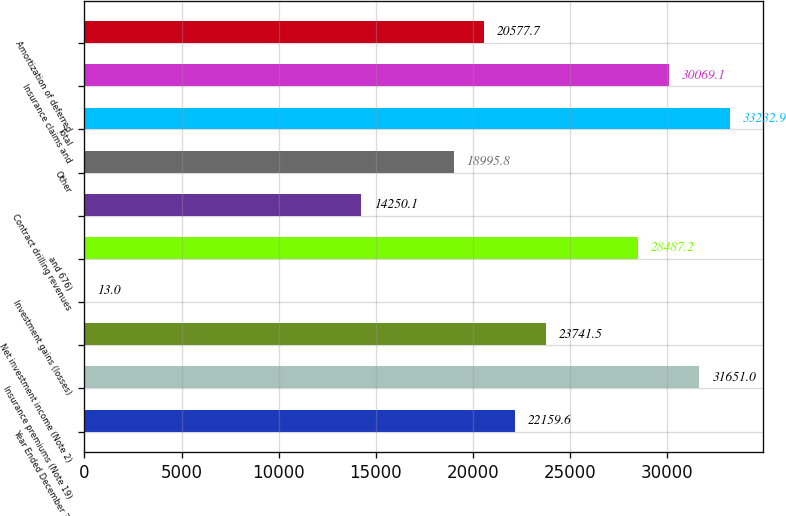Convert chart to OTSL. <chart><loc_0><loc_0><loc_500><loc_500><bar_chart><fcel>Year Ended December 31<fcel>Insurance premiums (Note 19)<fcel>Net investment income (Note 2)<fcel>Investment gains (losses)<fcel>and 676)<fcel>Contract drilling revenues<fcel>Other<fcel>Total<fcel>Insurance claims and<fcel>Amortization of deferred<nl><fcel>22159.6<fcel>31651<fcel>23741.5<fcel>13<fcel>28487.2<fcel>14250.1<fcel>18995.8<fcel>33232.9<fcel>30069.1<fcel>20577.7<nl></chart> 